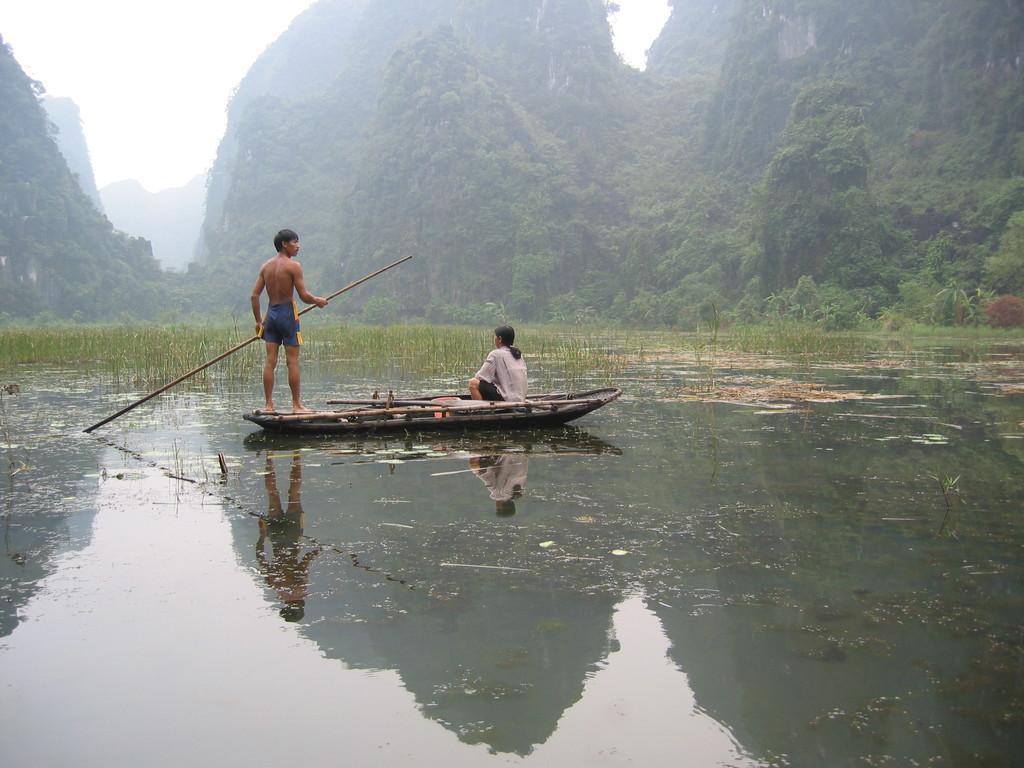Describe this image in one or two sentences. This image consists of two persons travelling in the boat. At the bottom, there is water. In the background, there are mountains which are covered with plants and trees. At the top, there is sky. 